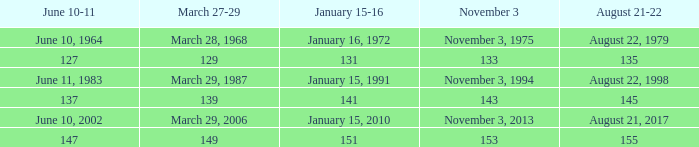What is shown for november 3 when june 10-11 is june 10, 1964? November 3, 1975. 